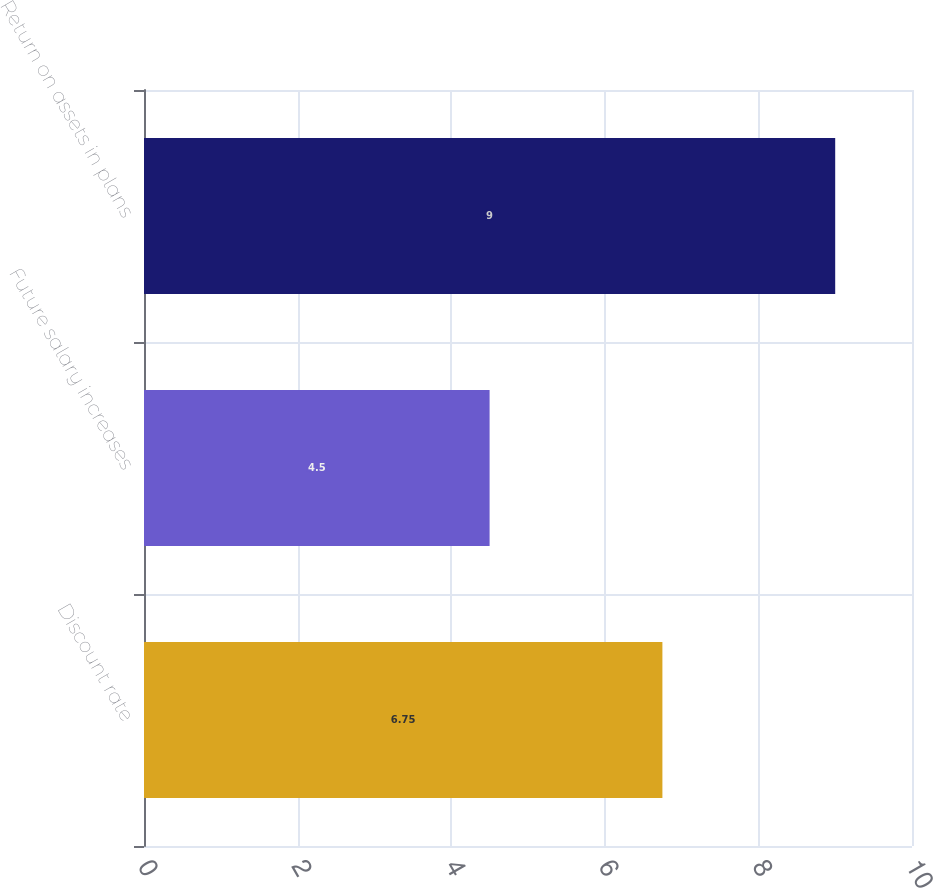<chart> <loc_0><loc_0><loc_500><loc_500><bar_chart><fcel>Discount rate<fcel>Future salary increases<fcel>Return on assets in plans<nl><fcel>6.75<fcel>4.5<fcel>9<nl></chart> 